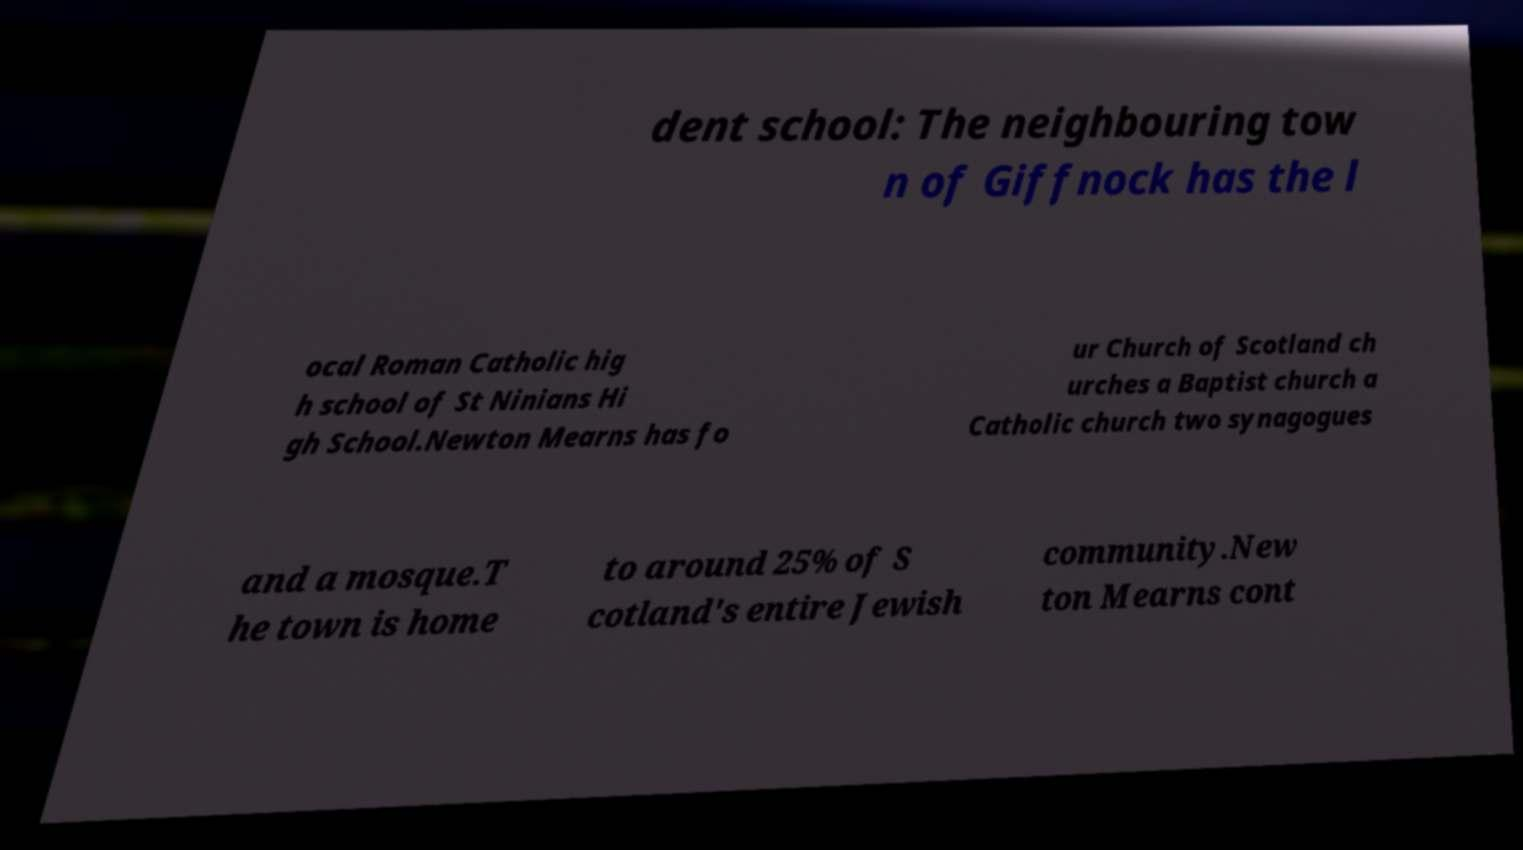Could you assist in decoding the text presented in this image and type it out clearly? dent school: The neighbouring tow n of Giffnock has the l ocal Roman Catholic hig h school of St Ninians Hi gh School.Newton Mearns has fo ur Church of Scotland ch urches a Baptist church a Catholic church two synagogues and a mosque.T he town is home to around 25% of S cotland's entire Jewish community.New ton Mearns cont 